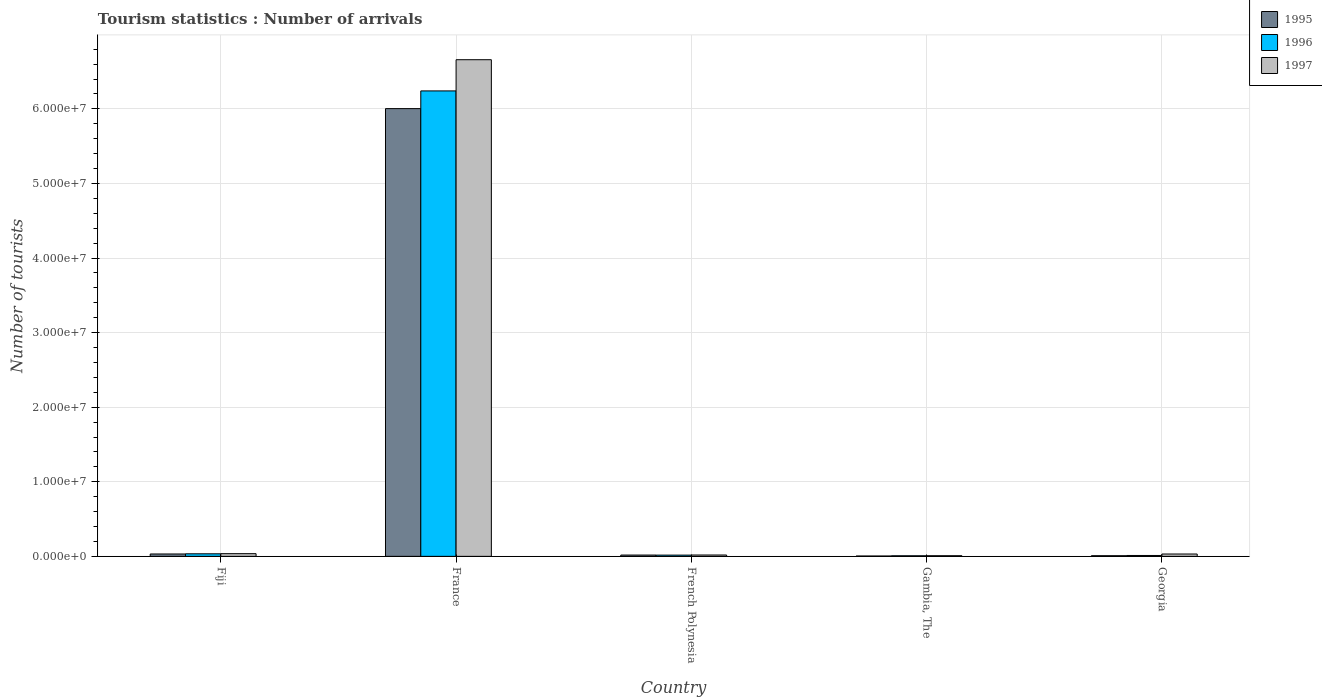How many different coloured bars are there?
Provide a short and direct response. 3. How many groups of bars are there?
Provide a succinct answer. 5. Are the number of bars on each tick of the X-axis equal?
Your answer should be compact. Yes. What is the label of the 3rd group of bars from the left?
Offer a very short reply. French Polynesia. In how many cases, is the number of bars for a given country not equal to the number of legend labels?
Make the answer very short. 0. What is the number of tourist arrivals in 1997 in Fiji?
Offer a very short reply. 3.59e+05. Across all countries, what is the maximum number of tourist arrivals in 1996?
Your answer should be very brief. 6.24e+07. Across all countries, what is the minimum number of tourist arrivals in 1995?
Make the answer very short. 4.50e+04. In which country was the number of tourist arrivals in 1995 maximum?
Provide a short and direct response. France. In which country was the number of tourist arrivals in 1995 minimum?
Offer a very short reply. Gambia, The. What is the total number of tourist arrivals in 1996 in the graph?
Make the answer very short. 6.31e+07. What is the difference between the number of tourist arrivals in 1997 in Fiji and that in France?
Your answer should be very brief. -6.62e+07. What is the difference between the number of tourist arrivals in 1997 in France and the number of tourist arrivals in 1995 in Georgia?
Offer a very short reply. 6.65e+07. What is the average number of tourist arrivals in 1996 per country?
Make the answer very short. 1.26e+07. What is the difference between the number of tourist arrivals of/in 1997 and number of tourist arrivals of/in 1995 in Georgia?
Your answer should be compact. 2.28e+05. What is the ratio of the number of tourist arrivals in 1996 in French Polynesia to that in Gambia, The?
Provide a succinct answer. 2.13. What is the difference between the highest and the second highest number of tourist arrivals in 1997?
Your answer should be compact. 6.62e+07. What is the difference between the highest and the lowest number of tourist arrivals in 1995?
Ensure brevity in your answer.  6.00e+07. In how many countries, is the number of tourist arrivals in 1996 greater than the average number of tourist arrivals in 1996 taken over all countries?
Offer a very short reply. 1. What does the 3rd bar from the left in Fiji represents?
Provide a succinct answer. 1997. How many bars are there?
Your answer should be compact. 15. How many countries are there in the graph?
Ensure brevity in your answer.  5. What is the difference between two consecutive major ticks on the Y-axis?
Offer a very short reply. 1.00e+07. Are the values on the major ticks of Y-axis written in scientific E-notation?
Give a very brief answer. Yes. Does the graph contain any zero values?
Your answer should be compact. No. Where does the legend appear in the graph?
Provide a succinct answer. Top right. How many legend labels are there?
Ensure brevity in your answer.  3. What is the title of the graph?
Offer a very short reply. Tourism statistics : Number of arrivals. Does "1997" appear as one of the legend labels in the graph?
Make the answer very short. Yes. What is the label or title of the X-axis?
Your answer should be compact. Country. What is the label or title of the Y-axis?
Provide a succinct answer. Number of tourists. What is the Number of tourists in 1995 in Fiji?
Ensure brevity in your answer.  3.18e+05. What is the Number of tourists of 1996 in Fiji?
Keep it short and to the point. 3.40e+05. What is the Number of tourists in 1997 in Fiji?
Make the answer very short. 3.59e+05. What is the Number of tourists in 1995 in France?
Your response must be concise. 6.00e+07. What is the Number of tourists of 1996 in France?
Keep it short and to the point. 6.24e+07. What is the Number of tourists of 1997 in France?
Your response must be concise. 6.66e+07. What is the Number of tourists of 1995 in French Polynesia?
Your answer should be compact. 1.72e+05. What is the Number of tourists of 1996 in French Polynesia?
Provide a short and direct response. 1.64e+05. What is the Number of tourists of 1997 in French Polynesia?
Your response must be concise. 1.80e+05. What is the Number of tourists in 1995 in Gambia, The?
Offer a terse response. 4.50e+04. What is the Number of tourists of 1996 in Gambia, The?
Provide a short and direct response. 7.70e+04. What is the Number of tourists of 1997 in Gambia, The?
Offer a terse response. 8.50e+04. What is the Number of tourists of 1995 in Georgia?
Give a very brief answer. 8.50e+04. What is the Number of tourists of 1996 in Georgia?
Give a very brief answer. 1.17e+05. What is the Number of tourists of 1997 in Georgia?
Your answer should be compact. 3.13e+05. Across all countries, what is the maximum Number of tourists of 1995?
Provide a succinct answer. 6.00e+07. Across all countries, what is the maximum Number of tourists of 1996?
Ensure brevity in your answer.  6.24e+07. Across all countries, what is the maximum Number of tourists in 1997?
Keep it short and to the point. 6.66e+07. Across all countries, what is the minimum Number of tourists in 1995?
Provide a succinct answer. 4.50e+04. Across all countries, what is the minimum Number of tourists of 1996?
Your response must be concise. 7.70e+04. Across all countries, what is the minimum Number of tourists in 1997?
Provide a succinct answer. 8.50e+04. What is the total Number of tourists of 1995 in the graph?
Offer a terse response. 6.07e+07. What is the total Number of tourists in 1996 in the graph?
Keep it short and to the point. 6.31e+07. What is the total Number of tourists of 1997 in the graph?
Keep it short and to the point. 6.75e+07. What is the difference between the Number of tourists in 1995 in Fiji and that in France?
Your answer should be compact. -5.97e+07. What is the difference between the Number of tourists of 1996 in Fiji and that in France?
Make the answer very short. -6.21e+07. What is the difference between the Number of tourists of 1997 in Fiji and that in France?
Your answer should be very brief. -6.62e+07. What is the difference between the Number of tourists in 1995 in Fiji and that in French Polynesia?
Your answer should be very brief. 1.46e+05. What is the difference between the Number of tourists of 1996 in Fiji and that in French Polynesia?
Your answer should be compact. 1.76e+05. What is the difference between the Number of tourists in 1997 in Fiji and that in French Polynesia?
Offer a very short reply. 1.79e+05. What is the difference between the Number of tourists in 1995 in Fiji and that in Gambia, The?
Make the answer very short. 2.73e+05. What is the difference between the Number of tourists in 1996 in Fiji and that in Gambia, The?
Provide a short and direct response. 2.63e+05. What is the difference between the Number of tourists of 1997 in Fiji and that in Gambia, The?
Keep it short and to the point. 2.74e+05. What is the difference between the Number of tourists of 1995 in Fiji and that in Georgia?
Provide a short and direct response. 2.33e+05. What is the difference between the Number of tourists of 1996 in Fiji and that in Georgia?
Give a very brief answer. 2.23e+05. What is the difference between the Number of tourists of 1997 in Fiji and that in Georgia?
Provide a succinct answer. 4.60e+04. What is the difference between the Number of tourists of 1995 in France and that in French Polynesia?
Offer a terse response. 5.99e+07. What is the difference between the Number of tourists of 1996 in France and that in French Polynesia?
Make the answer very short. 6.22e+07. What is the difference between the Number of tourists of 1997 in France and that in French Polynesia?
Your answer should be compact. 6.64e+07. What is the difference between the Number of tourists in 1995 in France and that in Gambia, The?
Your answer should be compact. 6.00e+07. What is the difference between the Number of tourists of 1996 in France and that in Gambia, The?
Provide a short and direct response. 6.23e+07. What is the difference between the Number of tourists of 1997 in France and that in Gambia, The?
Offer a very short reply. 6.65e+07. What is the difference between the Number of tourists in 1995 in France and that in Georgia?
Provide a succinct answer. 5.99e+07. What is the difference between the Number of tourists in 1996 in France and that in Georgia?
Ensure brevity in your answer.  6.23e+07. What is the difference between the Number of tourists in 1997 in France and that in Georgia?
Provide a short and direct response. 6.63e+07. What is the difference between the Number of tourists in 1995 in French Polynesia and that in Gambia, The?
Keep it short and to the point. 1.27e+05. What is the difference between the Number of tourists in 1996 in French Polynesia and that in Gambia, The?
Keep it short and to the point. 8.70e+04. What is the difference between the Number of tourists in 1997 in French Polynesia and that in Gambia, The?
Offer a terse response. 9.50e+04. What is the difference between the Number of tourists of 1995 in French Polynesia and that in Georgia?
Provide a succinct answer. 8.70e+04. What is the difference between the Number of tourists of 1996 in French Polynesia and that in Georgia?
Ensure brevity in your answer.  4.70e+04. What is the difference between the Number of tourists in 1997 in French Polynesia and that in Georgia?
Ensure brevity in your answer.  -1.33e+05. What is the difference between the Number of tourists in 1995 in Gambia, The and that in Georgia?
Keep it short and to the point. -4.00e+04. What is the difference between the Number of tourists of 1997 in Gambia, The and that in Georgia?
Offer a terse response. -2.28e+05. What is the difference between the Number of tourists in 1995 in Fiji and the Number of tourists in 1996 in France?
Your response must be concise. -6.21e+07. What is the difference between the Number of tourists of 1995 in Fiji and the Number of tourists of 1997 in France?
Offer a terse response. -6.63e+07. What is the difference between the Number of tourists in 1996 in Fiji and the Number of tourists in 1997 in France?
Your answer should be very brief. -6.63e+07. What is the difference between the Number of tourists of 1995 in Fiji and the Number of tourists of 1996 in French Polynesia?
Provide a succinct answer. 1.54e+05. What is the difference between the Number of tourists of 1995 in Fiji and the Number of tourists of 1997 in French Polynesia?
Make the answer very short. 1.38e+05. What is the difference between the Number of tourists in 1996 in Fiji and the Number of tourists in 1997 in French Polynesia?
Provide a succinct answer. 1.60e+05. What is the difference between the Number of tourists of 1995 in Fiji and the Number of tourists of 1996 in Gambia, The?
Offer a very short reply. 2.41e+05. What is the difference between the Number of tourists of 1995 in Fiji and the Number of tourists of 1997 in Gambia, The?
Provide a short and direct response. 2.33e+05. What is the difference between the Number of tourists in 1996 in Fiji and the Number of tourists in 1997 in Gambia, The?
Offer a very short reply. 2.55e+05. What is the difference between the Number of tourists in 1995 in Fiji and the Number of tourists in 1996 in Georgia?
Offer a very short reply. 2.01e+05. What is the difference between the Number of tourists in 1996 in Fiji and the Number of tourists in 1997 in Georgia?
Your answer should be very brief. 2.70e+04. What is the difference between the Number of tourists of 1995 in France and the Number of tourists of 1996 in French Polynesia?
Keep it short and to the point. 5.99e+07. What is the difference between the Number of tourists of 1995 in France and the Number of tourists of 1997 in French Polynesia?
Keep it short and to the point. 5.99e+07. What is the difference between the Number of tourists in 1996 in France and the Number of tourists in 1997 in French Polynesia?
Provide a succinct answer. 6.22e+07. What is the difference between the Number of tourists of 1995 in France and the Number of tourists of 1996 in Gambia, The?
Your response must be concise. 6.00e+07. What is the difference between the Number of tourists of 1995 in France and the Number of tourists of 1997 in Gambia, The?
Ensure brevity in your answer.  5.99e+07. What is the difference between the Number of tourists in 1996 in France and the Number of tourists in 1997 in Gambia, The?
Your answer should be compact. 6.23e+07. What is the difference between the Number of tourists in 1995 in France and the Number of tourists in 1996 in Georgia?
Ensure brevity in your answer.  5.99e+07. What is the difference between the Number of tourists of 1995 in France and the Number of tourists of 1997 in Georgia?
Give a very brief answer. 5.97e+07. What is the difference between the Number of tourists of 1996 in France and the Number of tourists of 1997 in Georgia?
Give a very brief answer. 6.21e+07. What is the difference between the Number of tourists of 1995 in French Polynesia and the Number of tourists of 1996 in Gambia, The?
Your answer should be compact. 9.50e+04. What is the difference between the Number of tourists of 1995 in French Polynesia and the Number of tourists of 1997 in Gambia, The?
Make the answer very short. 8.70e+04. What is the difference between the Number of tourists of 1996 in French Polynesia and the Number of tourists of 1997 in Gambia, The?
Offer a terse response. 7.90e+04. What is the difference between the Number of tourists in 1995 in French Polynesia and the Number of tourists in 1996 in Georgia?
Your response must be concise. 5.50e+04. What is the difference between the Number of tourists of 1995 in French Polynesia and the Number of tourists of 1997 in Georgia?
Keep it short and to the point. -1.41e+05. What is the difference between the Number of tourists of 1996 in French Polynesia and the Number of tourists of 1997 in Georgia?
Your answer should be compact. -1.49e+05. What is the difference between the Number of tourists of 1995 in Gambia, The and the Number of tourists of 1996 in Georgia?
Offer a terse response. -7.20e+04. What is the difference between the Number of tourists in 1995 in Gambia, The and the Number of tourists in 1997 in Georgia?
Your answer should be very brief. -2.68e+05. What is the difference between the Number of tourists of 1996 in Gambia, The and the Number of tourists of 1997 in Georgia?
Offer a very short reply. -2.36e+05. What is the average Number of tourists in 1995 per country?
Give a very brief answer. 1.21e+07. What is the average Number of tourists in 1996 per country?
Your answer should be compact. 1.26e+07. What is the average Number of tourists in 1997 per country?
Ensure brevity in your answer.  1.35e+07. What is the difference between the Number of tourists in 1995 and Number of tourists in 1996 in Fiji?
Provide a short and direct response. -2.20e+04. What is the difference between the Number of tourists of 1995 and Number of tourists of 1997 in Fiji?
Keep it short and to the point. -4.10e+04. What is the difference between the Number of tourists of 1996 and Number of tourists of 1997 in Fiji?
Offer a very short reply. -1.90e+04. What is the difference between the Number of tourists of 1995 and Number of tourists of 1996 in France?
Give a very brief answer. -2.37e+06. What is the difference between the Number of tourists in 1995 and Number of tourists in 1997 in France?
Make the answer very short. -6.56e+06. What is the difference between the Number of tourists in 1996 and Number of tourists in 1997 in France?
Offer a terse response. -4.18e+06. What is the difference between the Number of tourists of 1995 and Number of tourists of 1996 in French Polynesia?
Your answer should be compact. 8000. What is the difference between the Number of tourists of 1995 and Number of tourists of 1997 in French Polynesia?
Ensure brevity in your answer.  -8000. What is the difference between the Number of tourists of 1996 and Number of tourists of 1997 in French Polynesia?
Your response must be concise. -1.60e+04. What is the difference between the Number of tourists of 1995 and Number of tourists of 1996 in Gambia, The?
Give a very brief answer. -3.20e+04. What is the difference between the Number of tourists in 1996 and Number of tourists in 1997 in Gambia, The?
Offer a very short reply. -8000. What is the difference between the Number of tourists in 1995 and Number of tourists in 1996 in Georgia?
Offer a terse response. -3.20e+04. What is the difference between the Number of tourists of 1995 and Number of tourists of 1997 in Georgia?
Provide a short and direct response. -2.28e+05. What is the difference between the Number of tourists of 1996 and Number of tourists of 1997 in Georgia?
Offer a terse response. -1.96e+05. What is the ratio of the Number of tourists in 1995 in Fiji to that in France?
Provide a succinct answer. 0.01. What is the ratio of the Number of tourists of 1996 in Fiji to that in France?
Provide a succinct answer. 0.01. What is the ratio of the Number of tourists of 1997 in Fiji to that in France?
Ensure brevity in your answer.  0.01. What is the ratio of the Number of tourists of 1995 in Fiji to that in French Polynesia?
Provide a short and direct response. 1.85. What is the ratio of the Number of tourists in 1996 in Fiji to that in French Polynesia?
Your answer should be very brief. 2.07. What is the ratio of the Number of tourists of 1997 in Fiji to that in French Polynesia?
Make the answer very short. 1.99. What is the ratio of the Number of tourists of 1995 in Fiji to that in Gambia, The?
Your answer should be compact. 7.07. What is the ratio of the Number of tourists of 1996 in Fiji to that in Gambia, The?
Make the answer very short. 4.42. What is the ratio of the Number of tourists of 1997 in Fiji to that in Gambia, The?
Give a very brief answer. 4.22. What is the ratio of the Number of tourists of 1995 in Fiji to that in Georgia?
Your answer should be very brief. 3.74. What is the ratio of the Number of tourists of 1996 in Fiji to that in Georgia?
Offer a very short reply. 2.91. What is the ratio of the Number of tourists in 1997 in Fiji to that in Georgia?
Offer a very short reply. 1.15. What is the ratio of the Number of tourists of 1995 in France to that in French Polynesia?
Keep it short and to the point. 349.03. What is the ratio of the Number of tourists of 1996 in France to that in French Polynesia?
Make the answer very short. 380.52. What is the ratio of the Number of tourists in 1997 in France to that in French Polynesia?
Keep it short and to the point. 369.95. What is the ratio of the Number of tourists in 1995 in France to that in Gambia, The?
Make the answer very short. 1334.07. What is the ratio of the Number of tourists of 1996 in France to that in Gambia, The?
Offer a terse response. 810.47. What is the ratio of the Number of tourists of 1997 in France to that in Gambia, The?
Give a very brief answer. 783.42. What is the ratio of the Number of tourists in 1995 in France to that in Georgia?
Provide a succinct answer. 706.27. What is the ratio of the Number of tourists of 1996 in France to that in Georgia?
Your answer should be very brief. 533.38. What is the ratio of the Number of tourists of 1997 in France to that in Georgia?
Give a very brief answer. 212.75. What is the ratio of the Number of tourists in 1995 in French Polynesia to that in Gambia, The?
Your answer should be compact. 3.82. What is the ratio of the Number of tourists in 1996 in French Polynesia to that in Gambia, The?
Your response must be concise. 2.13. What is the ratio of the Number of tourists in 1997 in French Polynesia to that in Gambia, The?
Ensure brevity in your answer.  2.12. What is the ratio of the Number of tourists in 1995 in French Polynesia to that in Georgia?
Offer a terse response. 2.02. What is the ratio of the Number of tourists in 1996 in French Polynesia to that in Georgia?
Offer a very short reply. 1.4. What is the ratio of the Number of tourists of 1997 in French Polynesia to that in Georgia?
Your answer should be compact. 0.58. What is the ratio of the Number of tourists of 1995 in Gambia, The to that in Georgia?
Provide a succinct answer. 0.53. What is the ratio of the Number of tourists in 1996 in Gambia, The to that in Georgia?
Offer a very short reply. 0.66. What is the ratio of the Number of tourists of 1997 in Gambia, The to that in Georgia?
Ensure brevity in your answer.  0.27. What is the difference between the highest and the second highest Number of tourists of 1995?
Provide a short and direct response. 5.97e+07. What is the difference between the highest and the second highest Number of tourists in 1996?
Ensure brevity in your answer.  6.21e+07. What is the difference between the highest and the second highest Number of tourists of 1997?
Your answer should be very brief. 6.62e+07. What is the difference between the highest and the lowest Number of tourists of 1995?
Keep it short and to the point. 6.00e+07. What is the difference between the highest and the lowest Number of tourists in 1996?
Provide a succinct answer. 6.23e+07. What is the difference between the highest and the lowest Number of tourists in 1997?
Ensure brevity in your answer.  6.65e+07. 